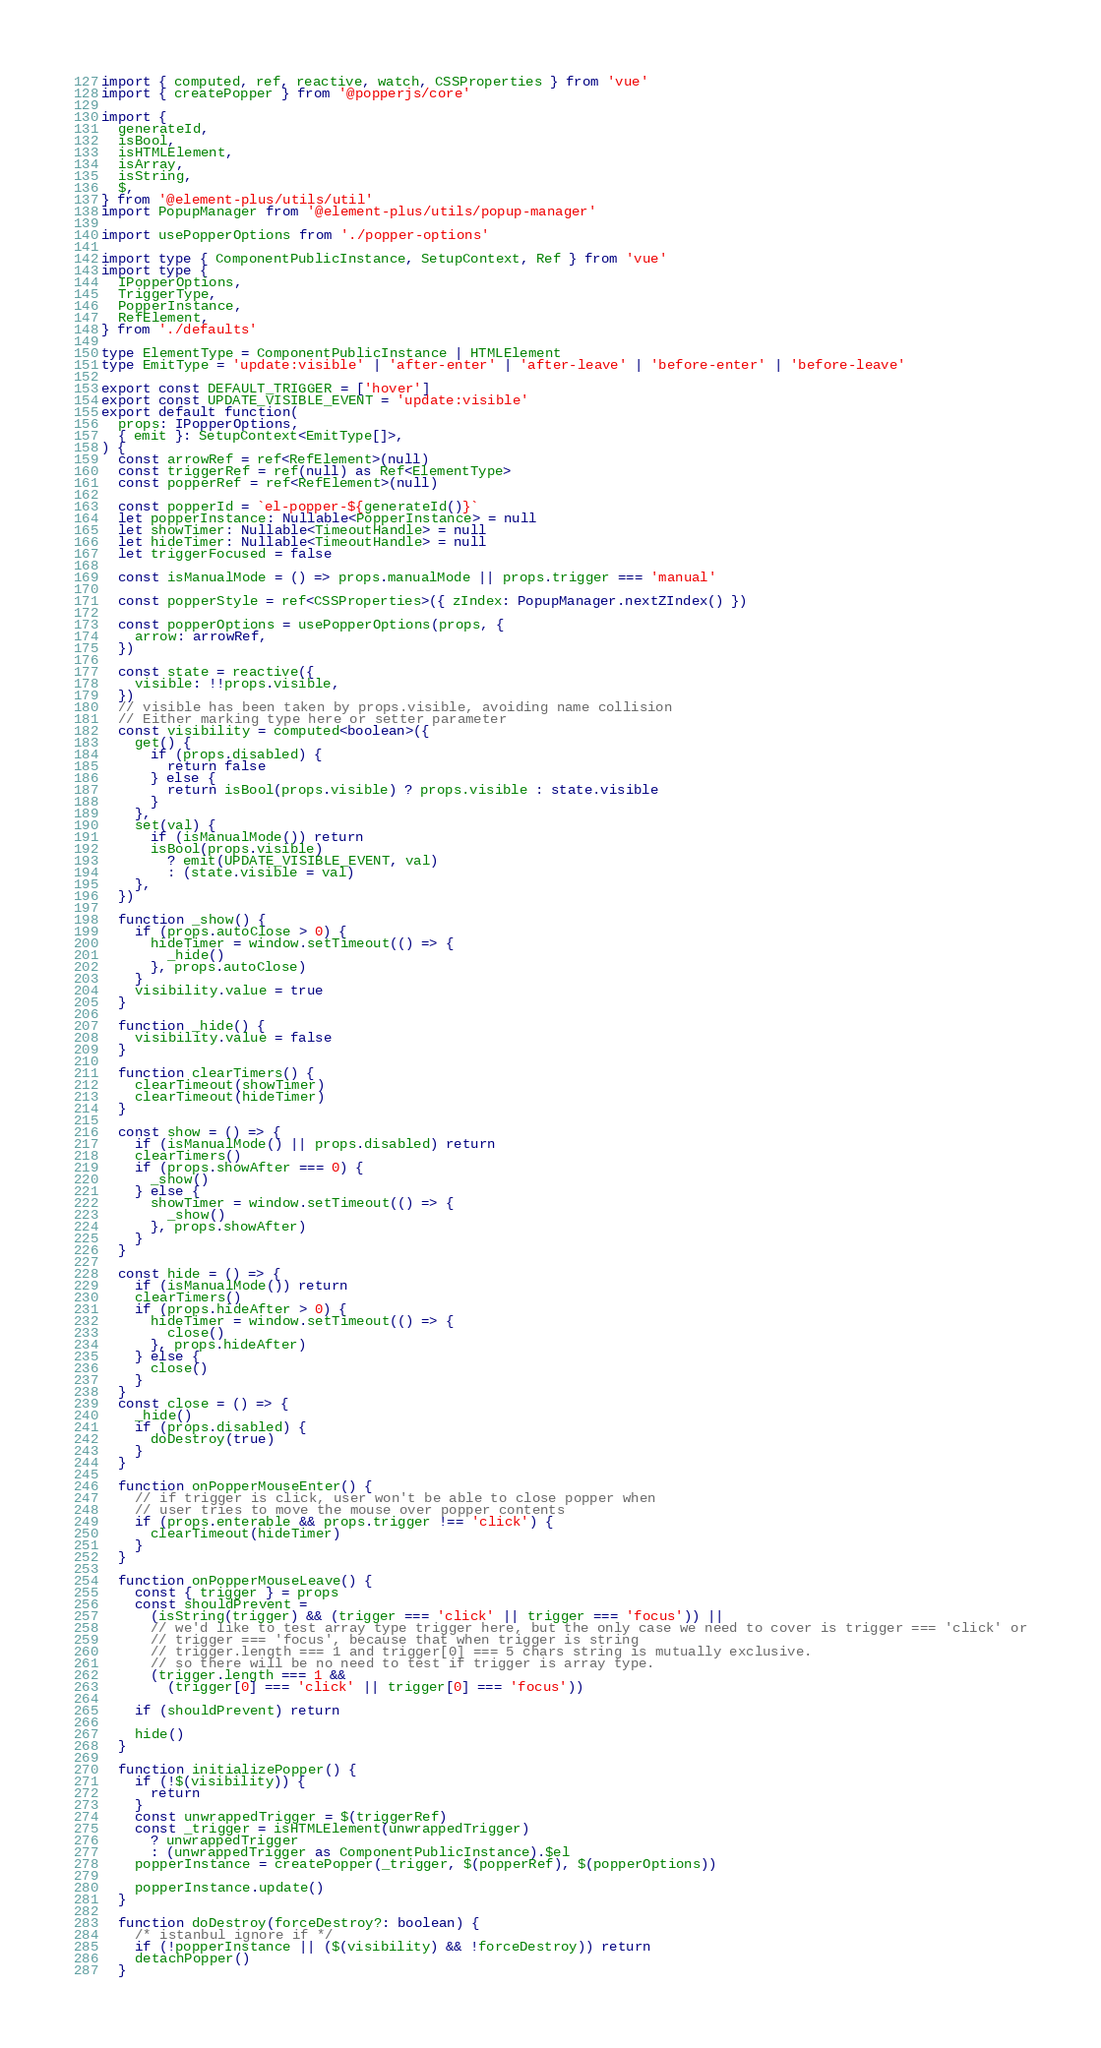<code> <loc_0><loc_0><loc_500><loc_500><_TypeScript_>import { computed, ref, reactive, watch, CSSProperties } from 'vue'
import { createPopper } from '@popperjs/core'

import {
  generateId,
  isBool,
  isHTMLElement,
  isArray,
  isString,
  $,
} from '@element-plus/utils/util'
import PopupManager from '@element-plus/utils/popup-manager'

import usePopperOptions from './popper-options'

import type { ComponentPublicInstance, SetupContext, Ref } from 'vue'
import type {
  IPopperOptions,
  TriggerType,
  PopperInstance,
  RefElement,
} from './defaults'

type ElementType = ComponentPublicInstance | HTMLElement
type EmitType = 'update:visible' | 'after-enter' | 'after-leave' | 'before-enter' | 'before-leave'

export const DEFAULT_TRIGGER = ['hover']
export const UPDATE_VISIBLE_EVENT = 'update:visible'
export default function(
  props: IPopperOptions,
  { emit }: SetupContext<EmitType[]>,
) {
  const arrowRef = ref<RefElement>(null)
  const triggerRef = ref(null) as Ref<ElementType>
  const popperRef = ref<RefElement>(null)

  const popperId = `el-popper-${generateId()}`
  let popperInstance: Nullable<PopperInstance> = null
  let showTimer: Nullable<TimeoutHandle> = null
  let hideTimer: Nullable<TimeoutHandle> = null
  let triggerFocused = false

  const isManualMode = () => props.manualMode || props.trigger === 'manual'

  const popperStyle = ref<CSSProperties>({ zIndex: PopupManager.nextZIndex() })

  const popperOptions = usePopperOptions(props, {
    arrow: arrowRef,
  })

  const state = reactive({
    visible: !!props.visible,
  })
  // visible has been taken by props.visible, avoiding name collision
  // Either marking type here or setter parameter
  const visibility = computed<boolean>({
    get() {
      if (props.disabled) {
        return false
      } else {
        return isBool(props.visible) ? props.visible : state.visible
      }
    },
    set(val) {
      if (isManualMode()) return
      isBool(props.visible)
        ? emit(UPDATE_VISIBLE_EVENT, val)
        : (state.visible = val)
    },
  })

  function _show() {
    if (props.autoClose > 0) {
      hideTimer = window.setTimeout(() => {
        _hide()
      }, props.autoClose)
    }
    visibility.value = true
  }

  function _hide() {
    visibility.value = false
  }

  function clearTimers() {
    clearTimeout(showTimer)
    clearTimeout(hideTimer)
  }

  const show = () => {
    if (isManualMode() || props.disabled) return
    clearTimers()
    if (props.showAfter === 0) {
      _show()
    } else {
      showTimer = window.setTimeout(() => {
        _show()
      }, props.showAfter)
    }
  }

  const hide = () => {
    if (isManualMode()) return
    clearTimers()
    if (props.hideAfter > 0) {
      hideTimer = window.setTimeout(() => {
        close()
      }, props.hideAfter)
    } else {
      close()
    }
  }
  const close = () => {
    _hide()
    if (props.disabled) {
      doDestroy(true)
    }
  }

  function onPopperMouseEnter() {
    // if trigger is click, user won't be able to close popper when
    // user tries to move the mouse over popper contents
    if (props.enterable && props.trigger !== 'click') {
      clearTimeout(hideTimer)
    }
  }

  function onPopperMouseLeave() {
    const { trigger } = props
    const shouldPrevent =
      (isString(trigger) && (trigger === 'click' || trigger === 'focus')) ||
      // we'd like to test array type trigger here, but the only case we need to cover is trigger === 'click' or
      // trigger === 'focus', because that when trigger is string
      // trigger.length === 1 and trigger[0] === 5 chars string is mutually exclusive.
      // so there will be no need to test if trigger is array type.
      (trigger.length === 1 &&
        (trigger[0] === 'click' || trigger[0] === 'focus'))

    if (shouldPrevent) return

    hide()
  }

  function initializePopper() {
    if (!$(visibility)) {
      return
    }
    const unwrappedTrigger = $(triggerRef)
    const _trigger = isHTMLElement(unwrappedTrigger)
      ? unwrappedTrigger
      : (unwrappedTrigger as ComponentPublicInstance).$el
    popperInstance = createPopper(_trigger, $(popperRef), $(popperOptions))

    popperInstance.update()
  }

  function doDestroy(forceDestroy?: boolean) {
    /* istanbul ignore if */
    if (!popperInstance || ($(visibility) && !forceDestroy)) return
    detachPopper()
  }
</code> 